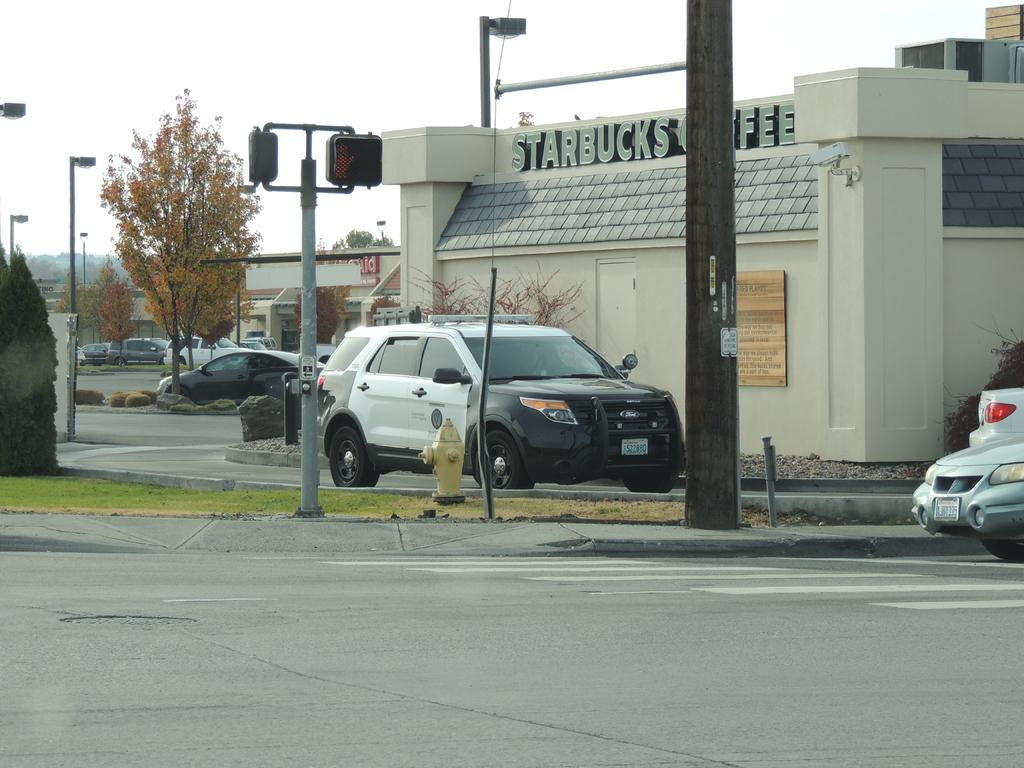What can be seen on the road in the image? There are vehicles on the road in the image. What structures are present in the image? There are buildings in the image. What type of lighting is present along the road? There are streetlights in the image. What is attached to a pole in the image? There is a board attached to a pole in the image. What safety feature is present in the image? There is a fire hydrant in the image. What type of vegetation can be seen in the image? There are trees and grass in the image. What part of the natural environment is visible in the image? The sky is visible in the image. What type of ice can be seen melting on the fire hydrant in the image? There is no ice present on the fire hydrant in the image. What type of trade is being conducted between the vehicles on the road in the image? There is no indication of any trade being conducted between the vehicles in the image. 